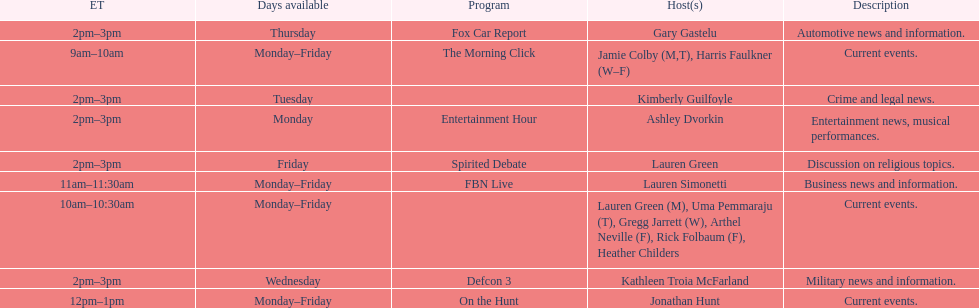How long does the show defcon 3 last? 1 hour. 